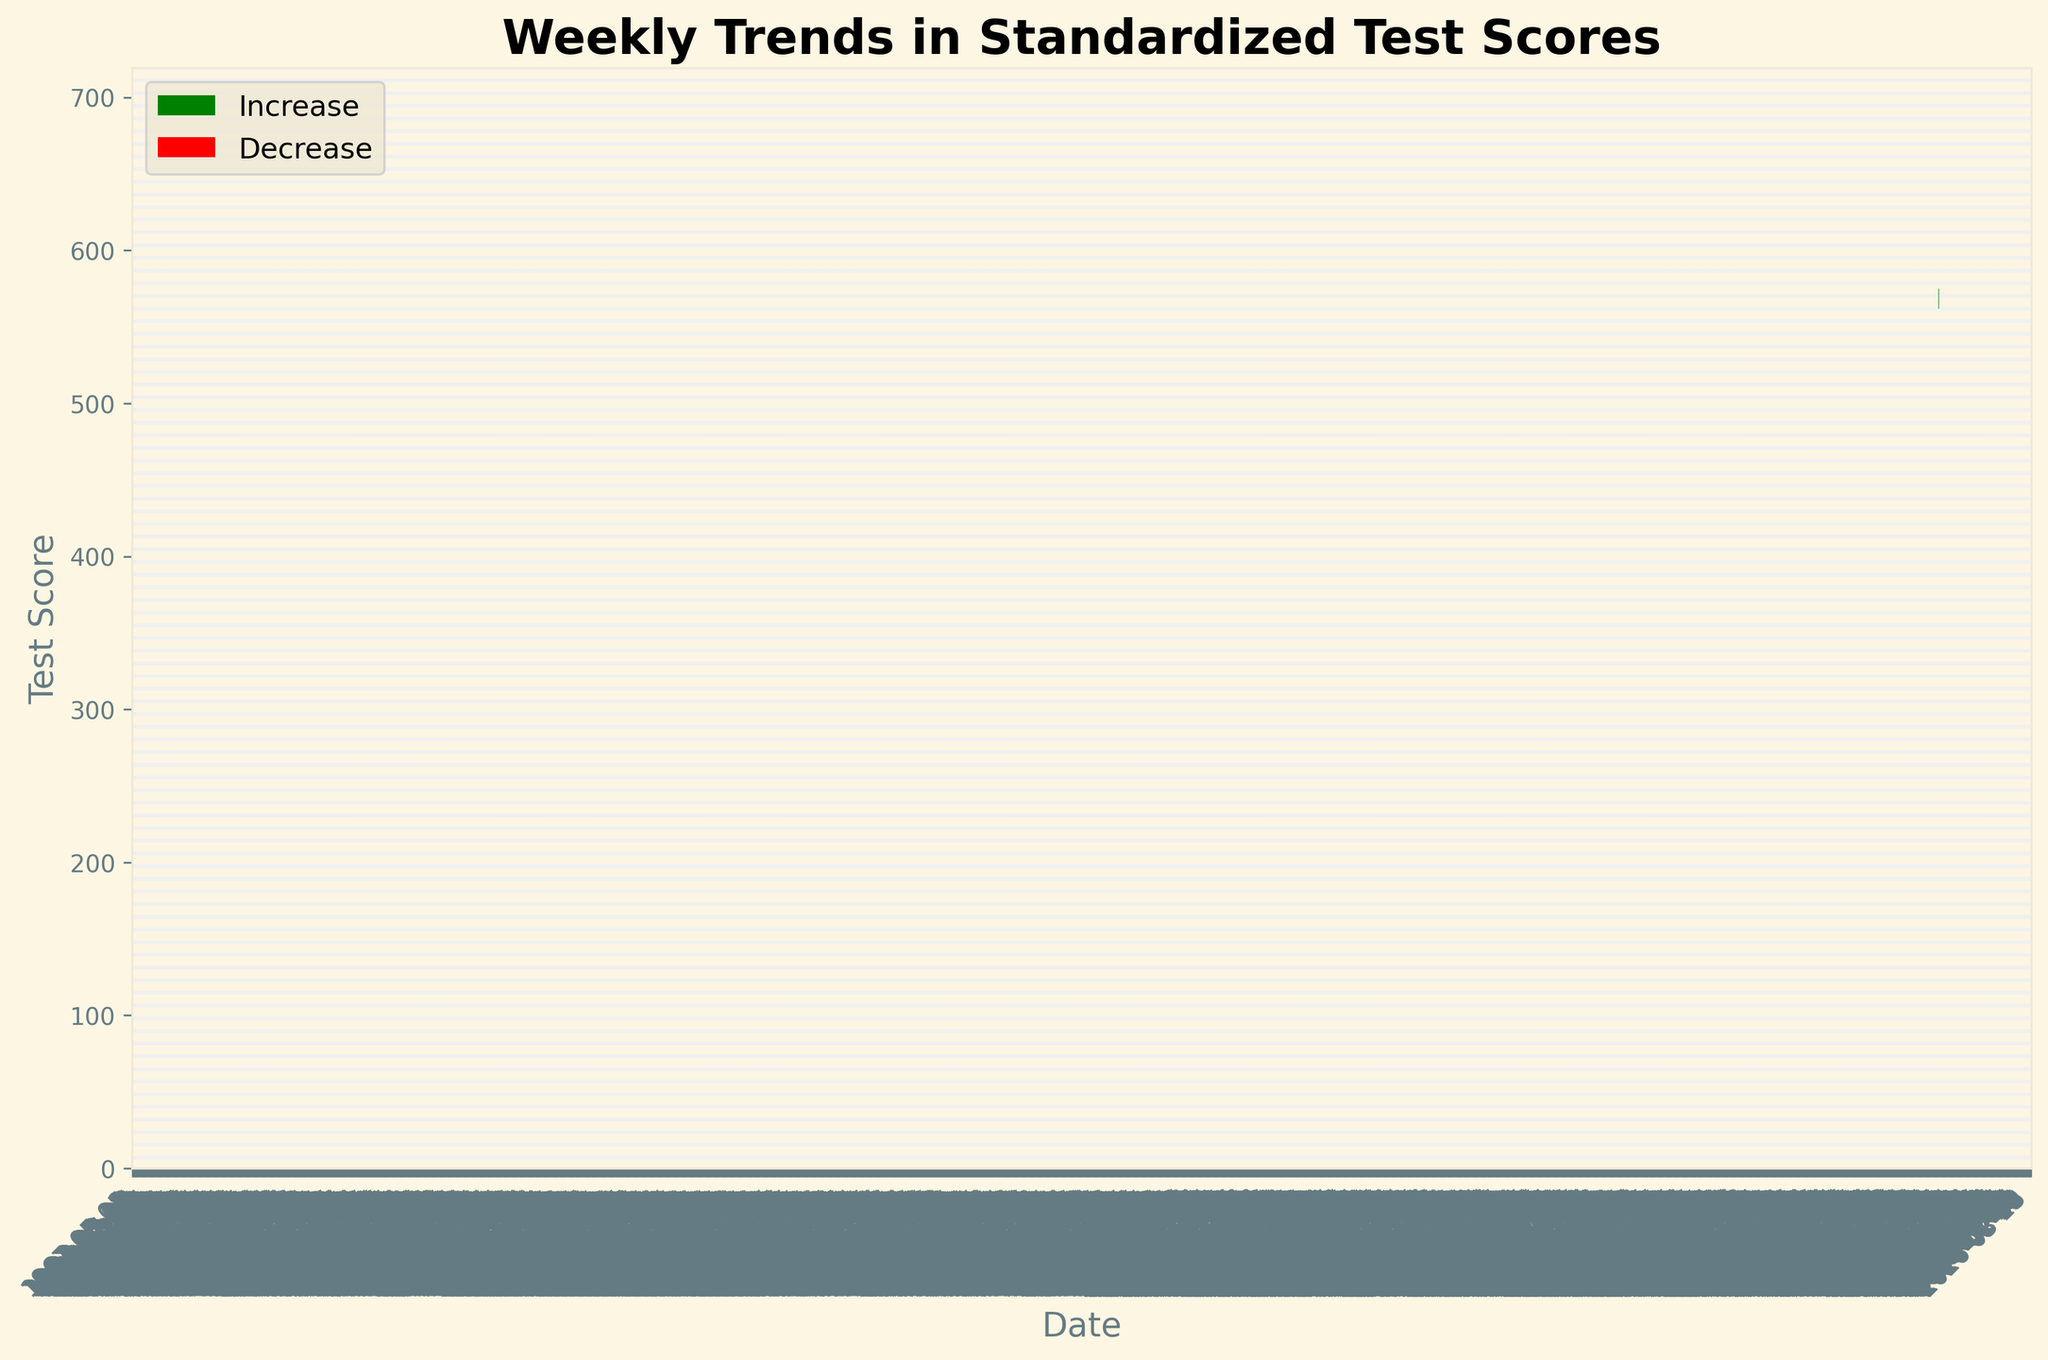What is the title of the figure? The title of the figure is located at the top of the plot. It reads 'Weekly Trends in Standardized Test Scores.'
Answer: Weekly Trends in Standardized Test Scores What is the range of dates displayed on the x-axis? The dates displayed on the x-axis range from '2023-05-01' to '2023-07-24,' as visible at the start and end of the axis.
Answer: 2023-05-01 to 2023-07-24 How many weeks show an increase in test scores? To determine the number of weeks with increasing scores, observe the green bars which indicate an increase. Count the number of green bars.
Answer: 13 weeks What was the highest score recorded in any week? Look for the highest value on the y-axis and find the corresponding highest point on the plot. The highest score recorded is in the week of '2023-07-24' with a high of '685.'
Answer: 685 Which week had the lowest closing score? Identify the lowest point for the closing scores by observing both red and green bars. The week '2023-05-01' closes at '550,' which is the lowest closing score.
Answer: 2023-05-01 What is the difference between the highest and lowest 'Open' scores? Identify the highest and lowest 'Open' scores. The highest 'Open' score is '672' (week of '2023-07-24') and the lowest is '540' (week of '2023-05-01'). Calculate the difference: 672 - 540 = 132
Answer: 132 Which week had the highest increase in test scores from open to close? Examine the green bars to find the week with the largest difference between 'Open' and 'Close' scores. The week of '2023-06-05' shows the highest increase from '597' to '610,' a difference of '13.'
Answer: 2023-06-05 Did any week have the same opening and closing scores? Observe all the green and red bars where 'Open' and 'Close' are at the same level. No weeks show the same opening and closing scores.
Answer: No What trend can be observed over the 13-week period regarding the test scores? By inspecting the plot, observe that the test scores generally increase over the 13 weeks, indicating an upward trend.
Answer: Upward trend Between which consecutive weeks is the largest drop in the closing score observed? Compare the closing scores for each consecutive week to find the largest drop. The largest drop occurs between the weeks of '2023-05-08' (560) and '2023-05-01' (550), a drop of '10.'
Answer: 2023-05-08 to 2023-05-01 